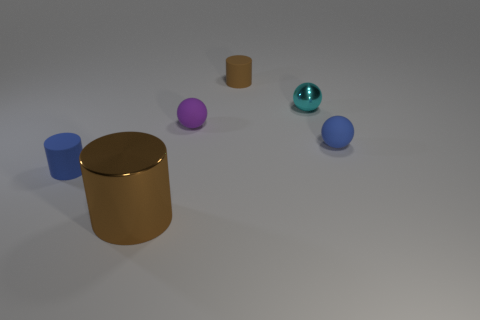What do the colors and shapes of the objects tell us about the context of this image? The image gives an impression of simplicity and abstraction, often indicative of a controlled environment like a studio setup. The colors are solid and distinct, suggesting they might be chosen for their contrast and ease of distinction. The spheres and cylinders may represent a variety of subjects or could be used for educational purposes, such as demonstrating geometric shapes, light and shadow, or color theory. The lack of additional context leaves the intent open to interpretation. 